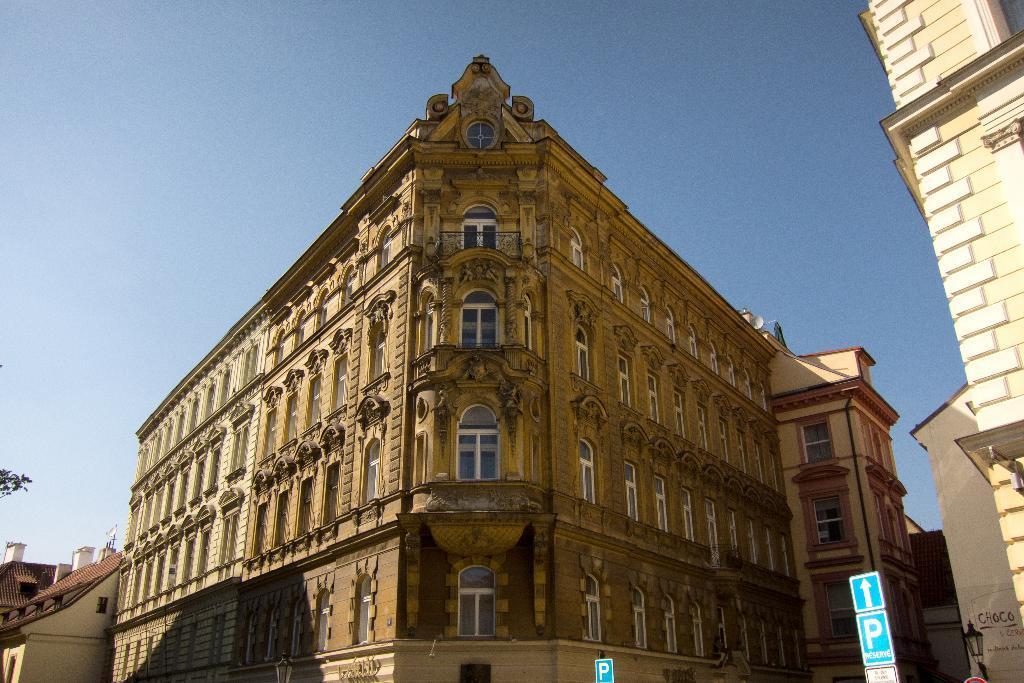Could you give a brief overview of what you see in this image? These are the buildings with the windows. At the bottom of the image, I can see the sign boards. This looks like a light. Here is the sky. 